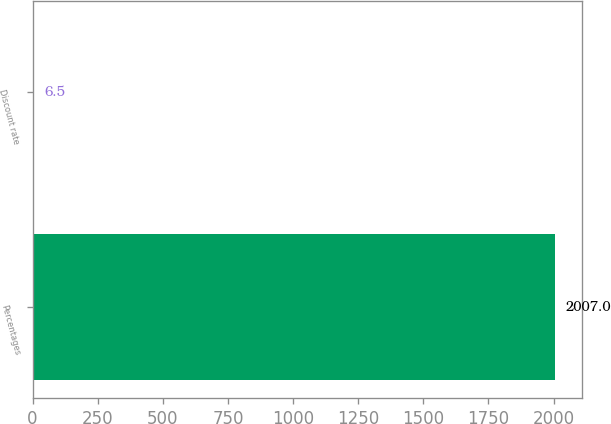Convert chart to OTSL. <chart><loc_0><loc_0><loc_500><loc_500><bar_chart><fcel>Percentages<fcel>Discount rate<nl><fcel>2007<fcel>6.5<nl></chart> 